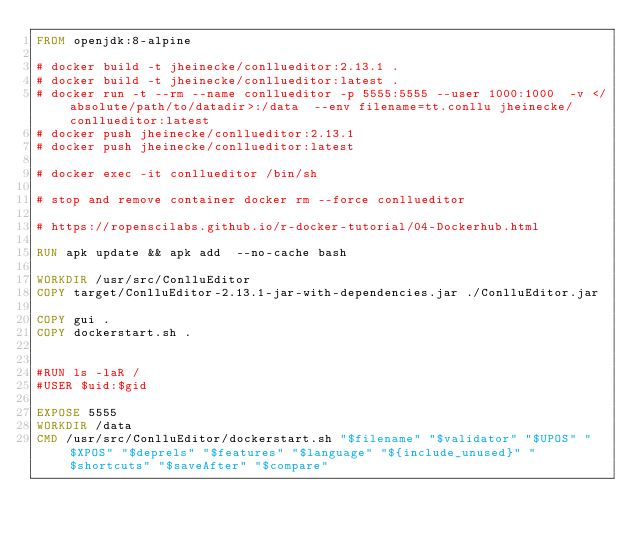<code> <loc_0><loc_0><loc_500><loc_500><_Dockerfile_>FROM openjdk:8-alpine

# docker build -t jheinecke/conllueditor:2.13.1 .
# docker build -t jheinecke/conllueditor:latest .
# docker run -t --rm --name conllueditor -p 5555:5555 --user 1000:1000  -v </absolute/path/to/datadir>:/data  --env filename=tt.conllu jheinecke/conllueditor:latest
# docker push jheinecke/conllueditor:2.13.1
# docker push jheinecke/conllueditor:latest

# docker exec -it conllueditor /bin/sh

# stop and remove container docker rm --force conllueditor

# https://ropenscilabs.github.io/r-docker-tutorial/04-Dockerhub.html

RUN apk update && apk add  --no-cache bash

WORKDIR /usr/src/ConlluEditor
COPY target/ConlluEditor-2.13.1-jar-with-dependencies.jar ./ConlluEditor.jar

COPY gui .
COPY dockerstart.sh .


#RUN ls -laR /
#USER $uid:$gid

EXPOSE 5555
WORKDIR /data
CMD /usr/src/ConlluEditor/dockerstart.sh "$filename" "$validator" "$UPOS" "$XPOS" "$deprels" "$features" "$language" "${include_unused}" "$shortcuts" "$saveAfter" "$compare"




</code> 